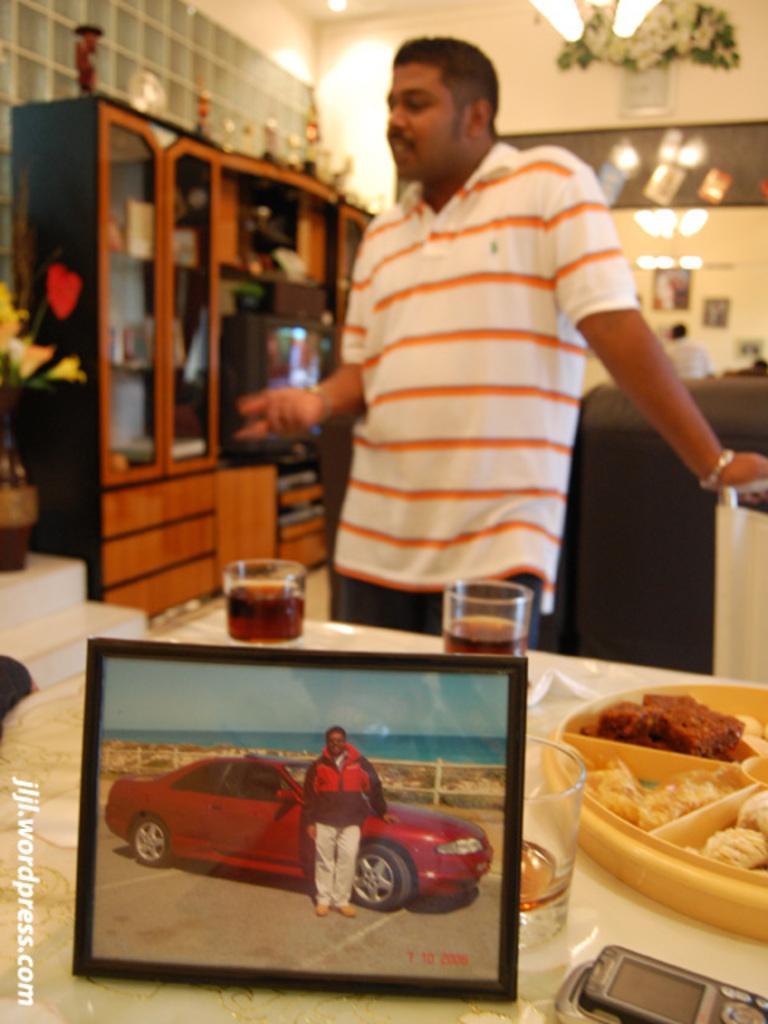In one or two sentences, can you explain what this image depicts? In the down side it is a photo, in this a man is standing near the car. In the middle a man is standing, he wore a t-shirt. There are wine glasses on this dining table. 